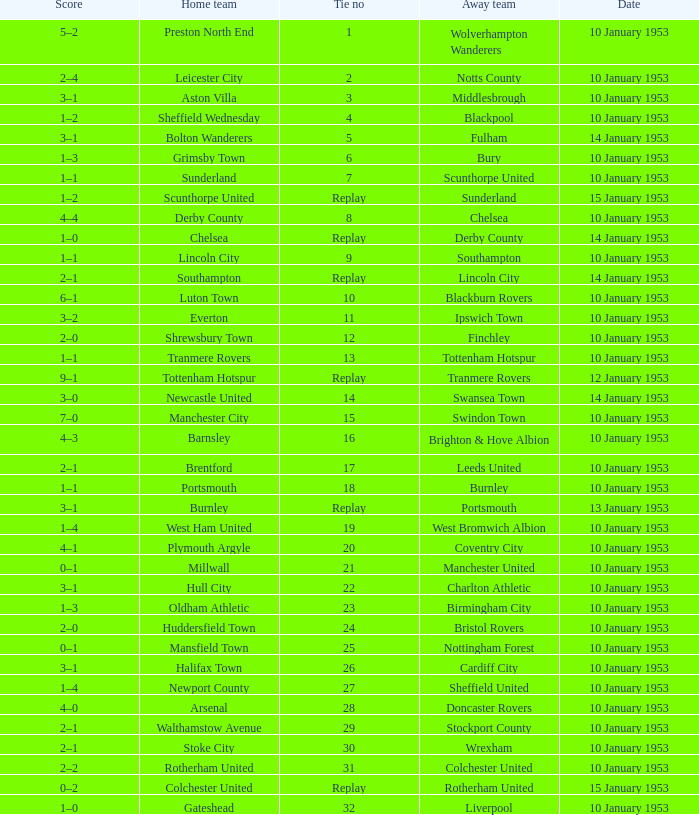What home team has coventry city as the away team? Plymouth Argyle. 